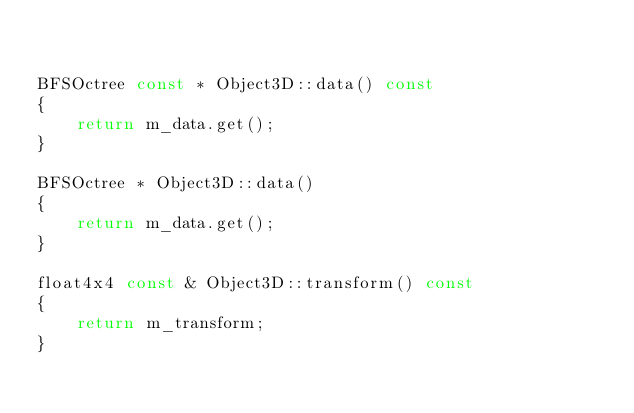Convert code to text. <code><loc_0><loc_0><loc_500><loc_500><_C++_>

BFSOctree const * Object3D::data() const
{
	return m_data.get();
}

BFSOctree * Object3D::data()
{
	return m_data.get();
}

float4x4 const & Object3D::transform() const
{
	return m_transform;
}</code> 